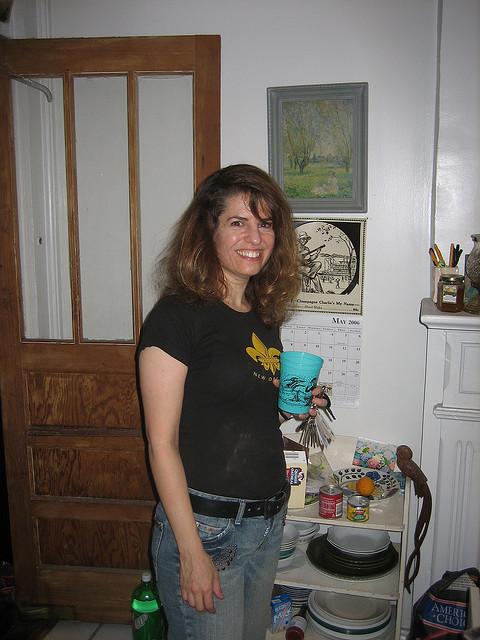Is she smiling?
Be succinct. Yes. Is she in a kitchen?
Be succinct. Yes. Is the woman hungry?
Concise answer only. No. What color is the pants of the lady?
Answer briefly. Blue. What hand is holding the cup?
Be succinct. Left. 